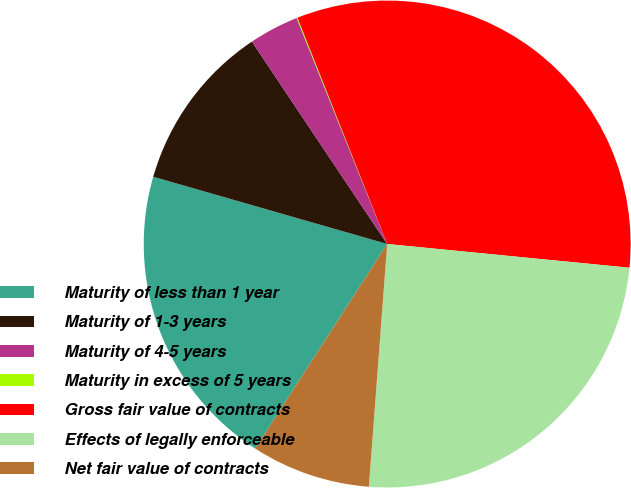Convert chart. <chart><loc_0><loc_0><loc_500><loc_500><pie_chart><fcel>Maturity of less than 1 year<fcel>Maturity of 1-3 years<fcel>Maturity of 4-5 years<fcel>Maturity in excess of 5 years<fcel>Gross fair value of contracts<fcel>Effects of legally enforceable<fcel>Net fair value of contracts<nl><fcel>20.34%<fcel>11.17%<fcel>3.31%<fcel>0.06%<fcel>32.57%<fcel>24.65%<fcel>7.92%<nl></chart> 